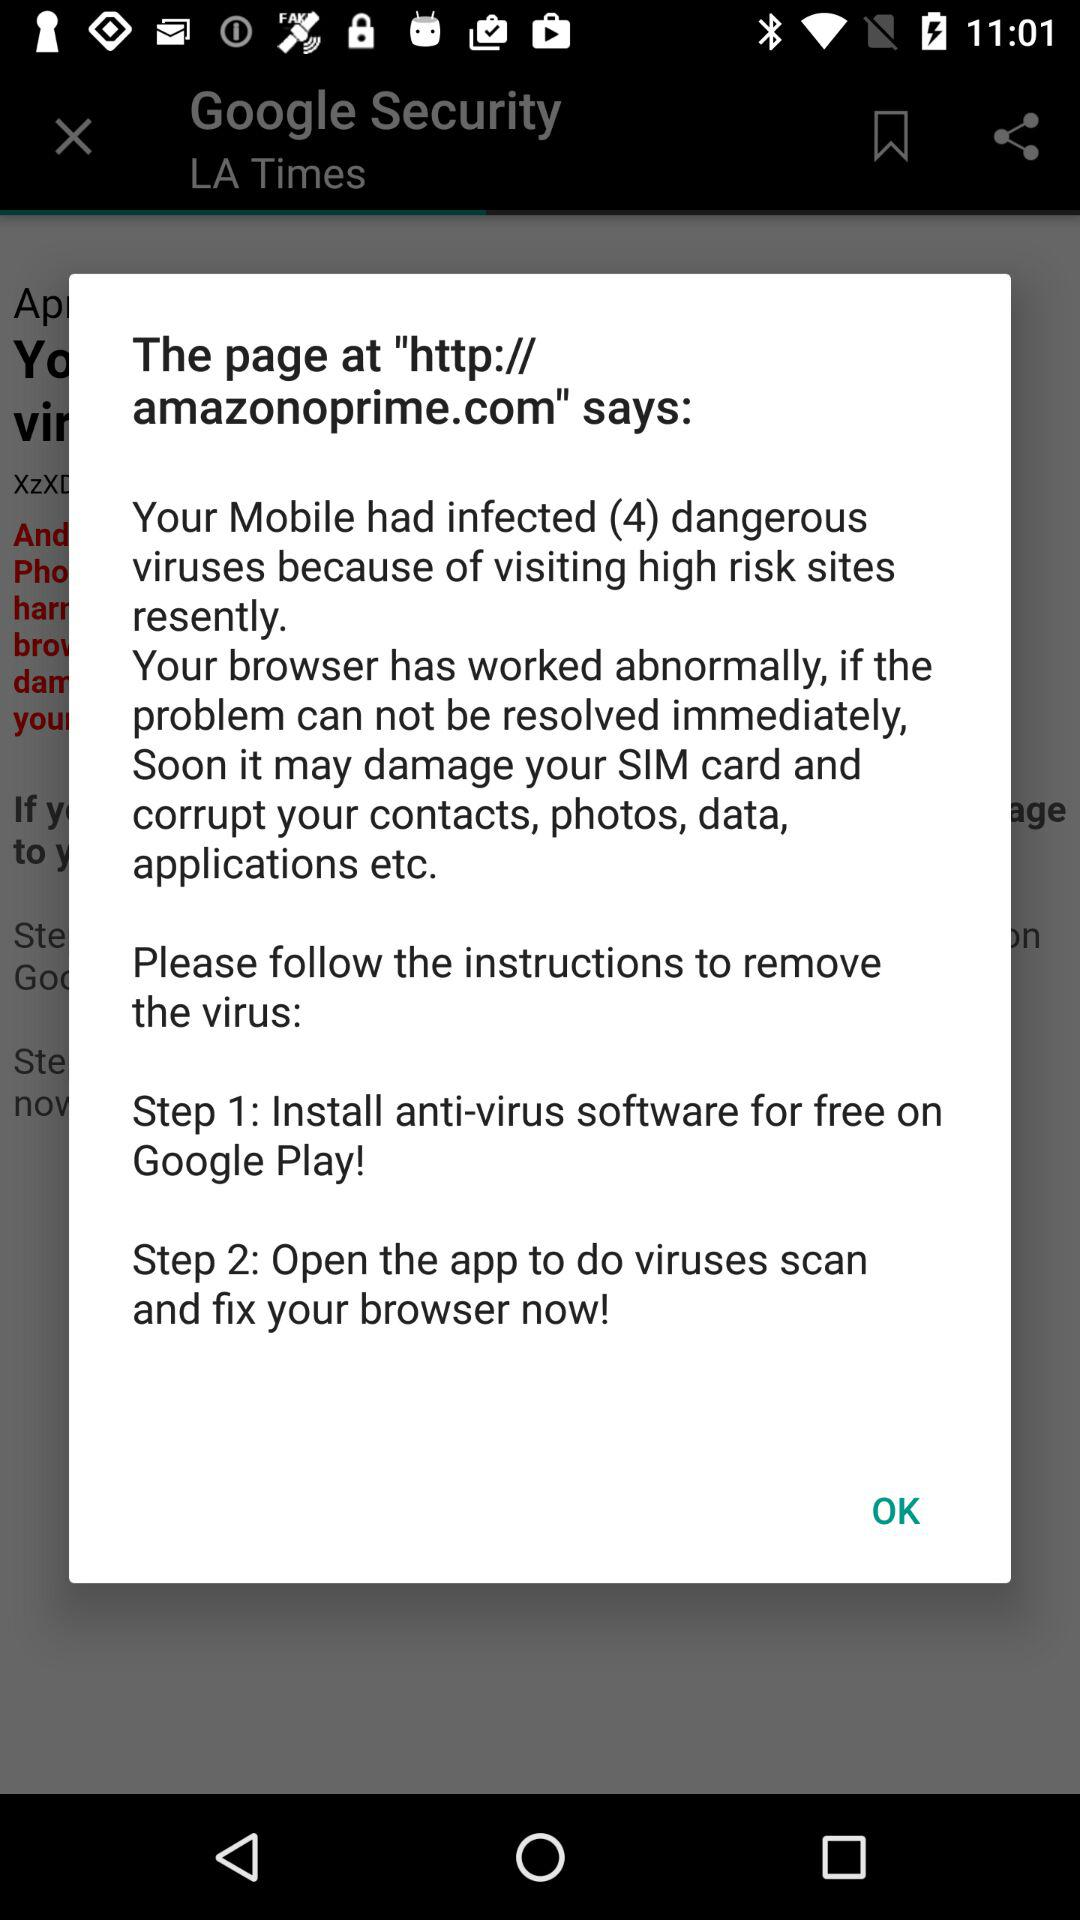How many viruses are there? There are 4 viruses. 